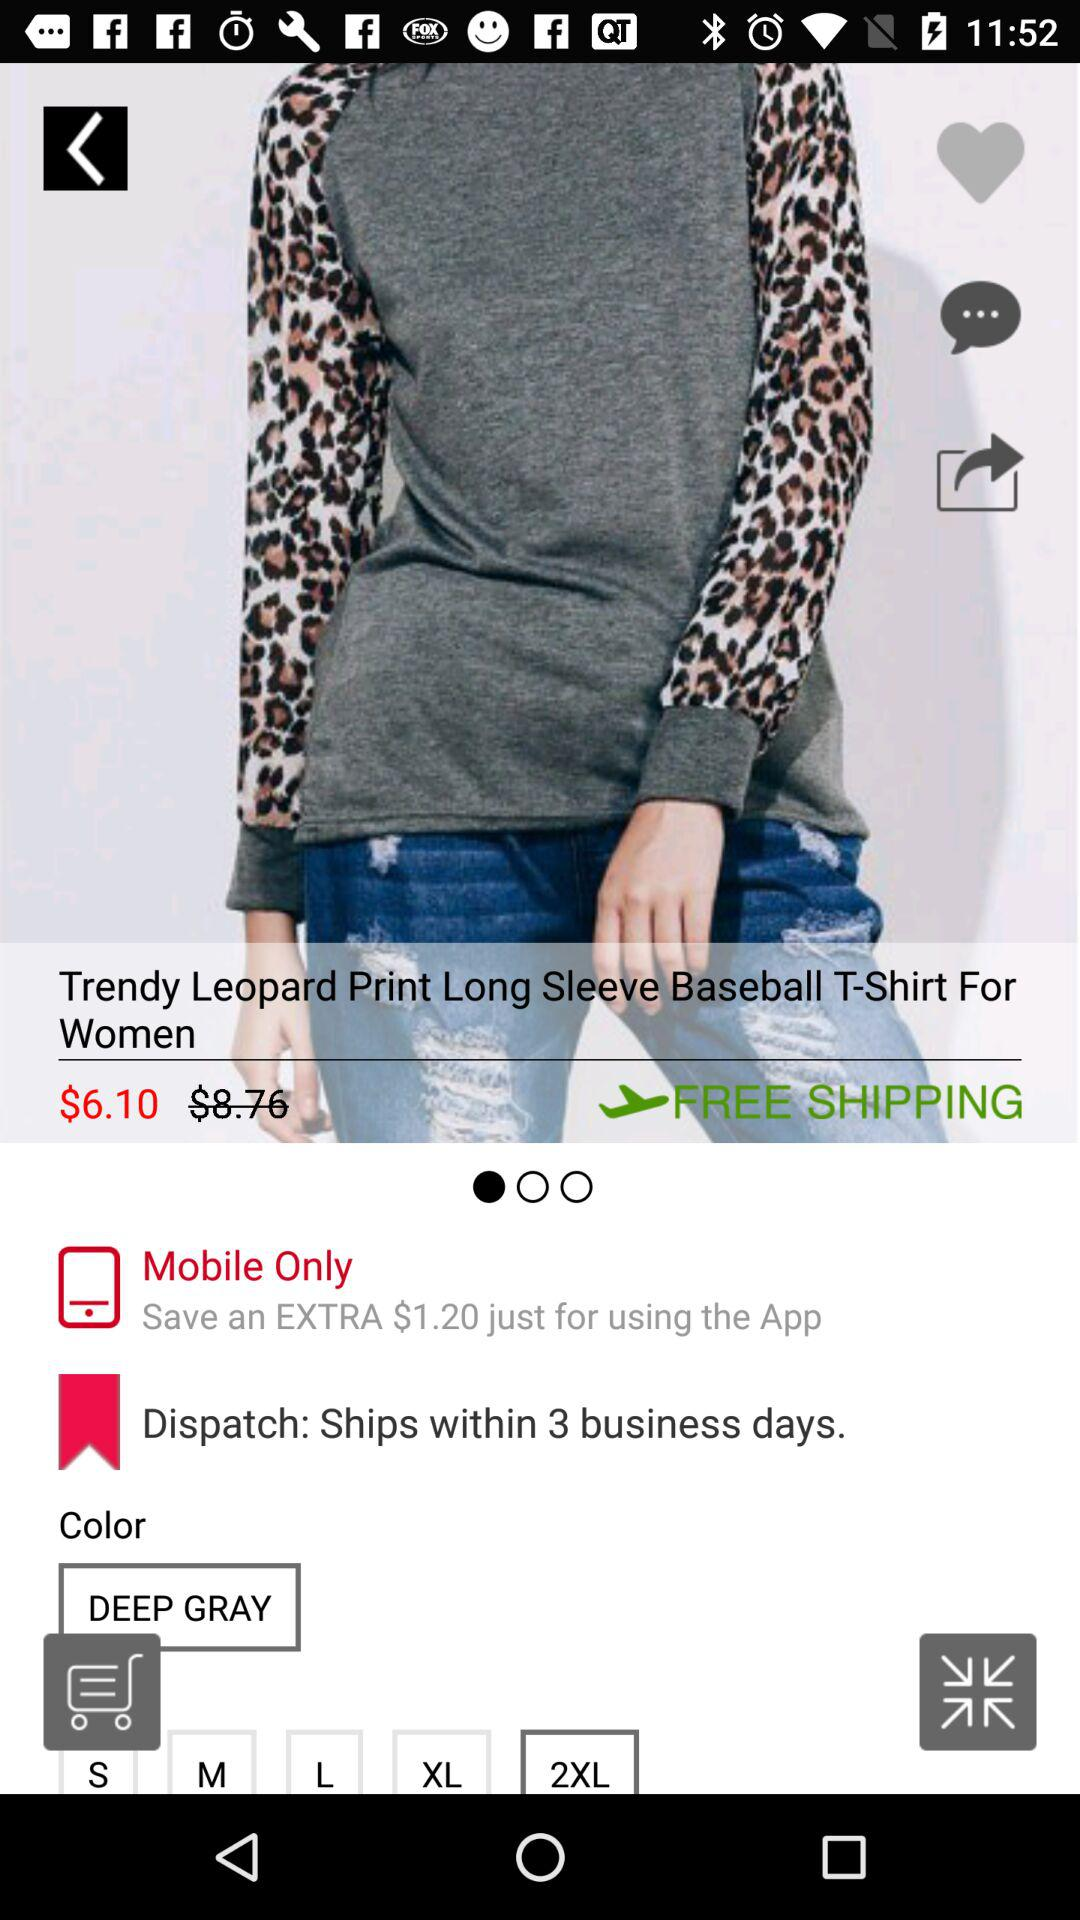Which color is available? The available color is deep gray. 